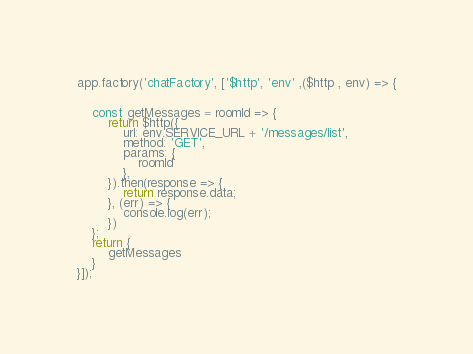<code> <loc_0><loc_0><loc_500><loc_500><_JavaScript_>app.factory('chatFactory', ['$http', 'env' ,($http , env) => {


    const getMessages = roomId => {
        return $http({
            url: env.SERVICE_URL + '/messages/list',
            method: 'GET',
            params: {
                roomId
            },
        }).then(response => {
            return response.data;
        }, (err) => {
            console.log(err);
        })
    };
    return {
        getMessages
    }
}]);</code> 